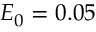<formula> <loc_0><loc_0><loc_500><loc_500>E _ { 0 } = 0 . 0 5</formula> 